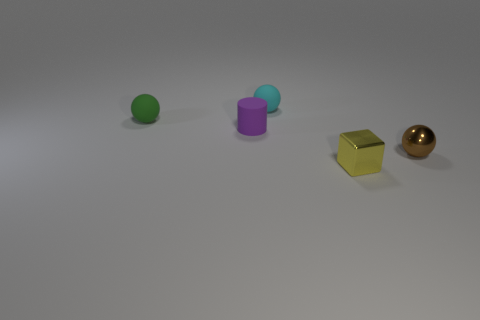There is a tiny green thing; is it the same shape as the tiny yellow metallic object that is on the right side of the green ball?
Offer a very short reply. No. The small brown metal thing has what shape?
Keep it short and to the point. Sphere. What is the material of the cylinder that is the same size as the yellow metallic block?
Ensure brevity in your answer.  Rubber. How many objects are small purple rubber things or balls that are on the left side of the yellow cube?
Provide a short and direct response. 3. There is a green ball that is made of the same material as the tiny cylinder; what is its size?
Your response must be concise. Small. The thing in front of the small metallic thing that is right of the tiny shiny block is what shape?
Your answer should be compact. Cube. Are there any green objects of the same shape as the cyan matte thing?
Your answer should be compact. Yes. Are there any other things that have the same shape as the small yellow thing?
Give a very brief answer. No. The small sphere that is to the right of the small object behind the tiny rubber object that is to the left of the tiny purple rubber cylinder is made of what material?
Provide a succinct answer. Metal. Is there a cyan rubber ball of the same size as the green matte ball?
Give a very brief answer. Yes. 